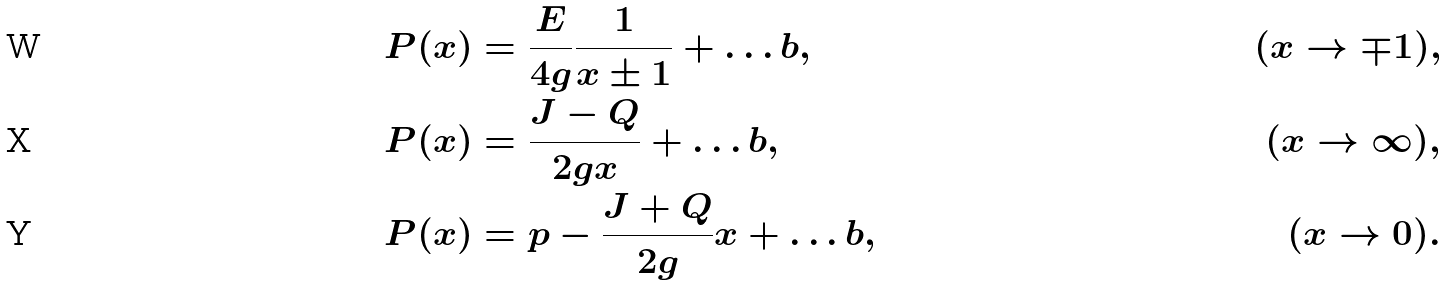<formula> <loc_0><loc_0><loc_500><loc_500>P ( x ) & = \frac { E } { 4 g } \frac { 1 } { x \pm 1 } + \dots b , & ( x \to \mp 1 ) , \\ P ( x ) & = \frac { J - Q } { 2 g x } + \dots b , & ( x \to \infty ) , \\ P ( x ) & = p - \frac { J + Q } { 2 g } x + \dots b , & ( x \to 0 ) .</formula> 